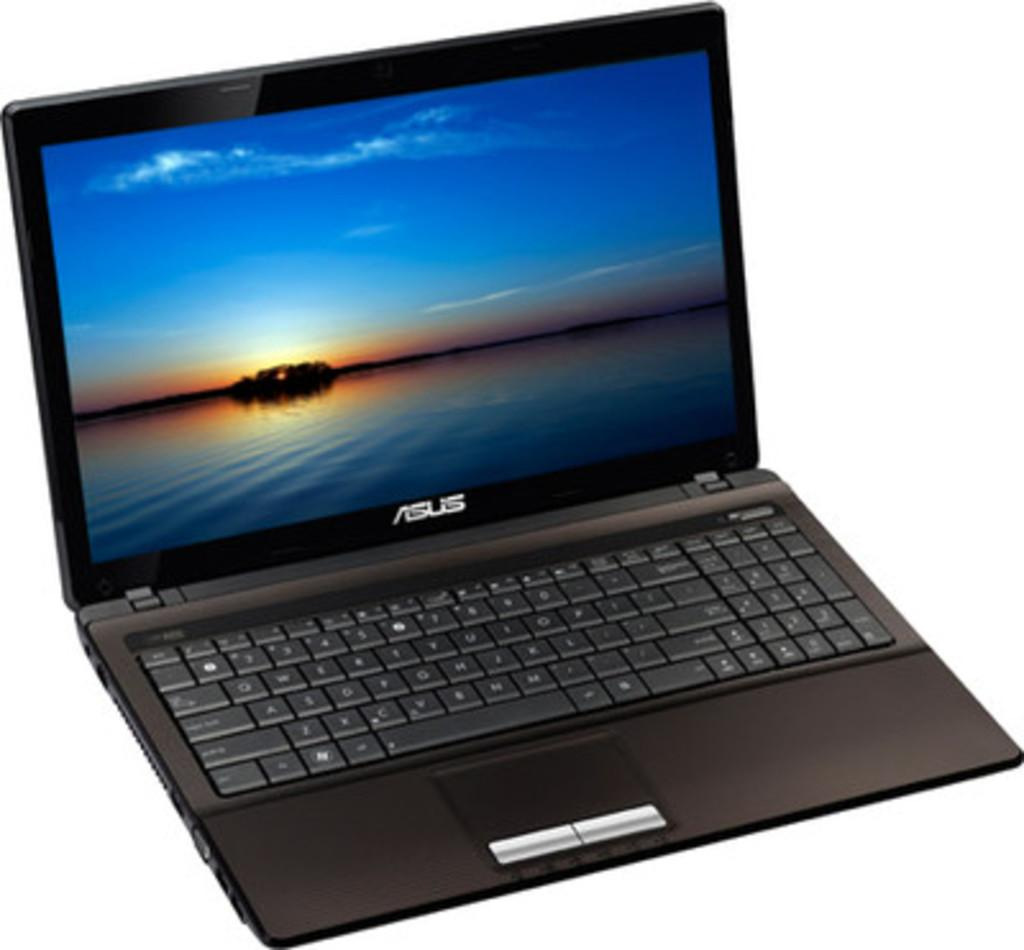<image>
Share a concise interpretation of the image provided. An Asus laptop computer is open to a screen with a blue sky on the horizon. 